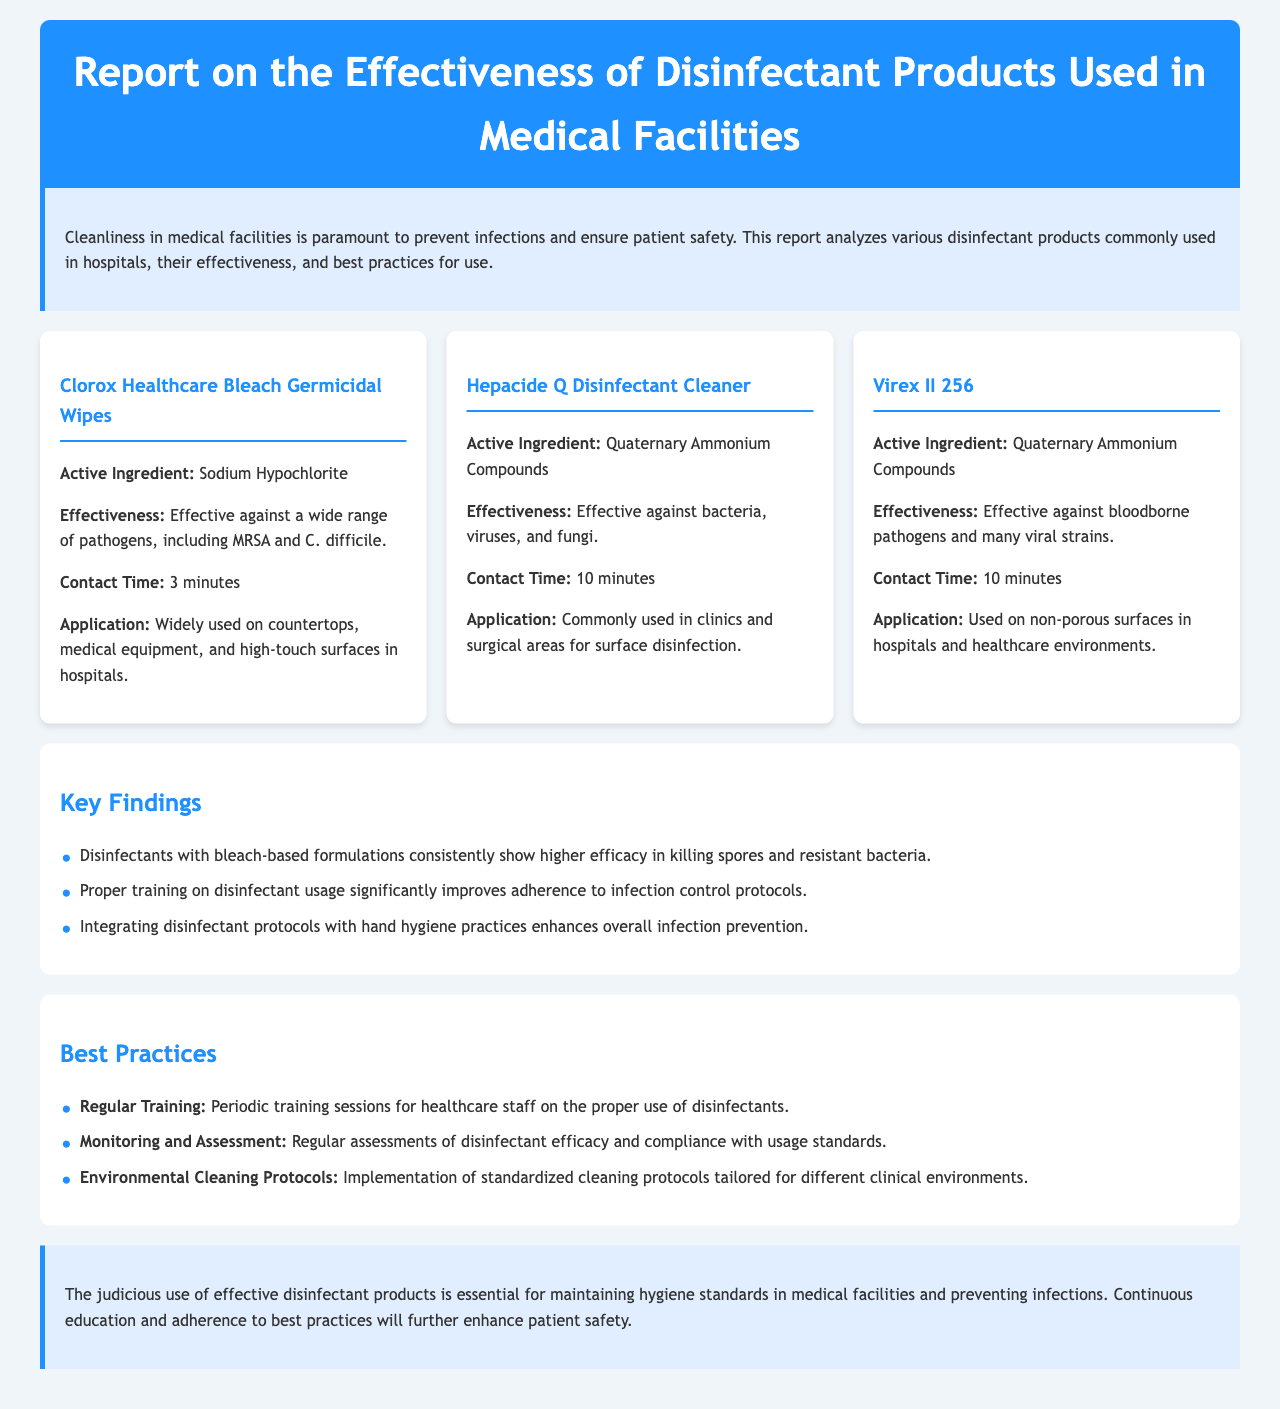What is the active ingredient in Clorox Healthcare Bleach Germicidal Wipes? The active ingredient mentioned in the document for Clorox Healthcare Bleach Germicidal Wipes is Sodium Hypochlorite.
Answer: Sodium Hypochlorite What environments is Hepacide Q Disinfectant Cleaner commonly used in? The document states that Hepacide Q Disinfectant Cleaner is commonly used in clinics and surgical areas for surface disinfection.
Answer: Clinics and surgical areas What is the contact time for Virex II 256? The document specifies that the contact time for Virex II 256 is 10 minutes.
Answer: 10 minutes Which disinfectant product is effective against a wide range of pathogens, including MRSA? Clorox Healthcare Bleach Germicidal Wipes is noted to be effective against a wide range of pathogens, including MRSA.
Answer: Clorox Healthcare Bleach Germicidal Wipes According to the findings, what enhances overall infection prevention? The findings suggest that integrating disinfectant protocols with hand hygiene practices enhances overall infection prevention.
Answer: Integrating disinfectant protocols with hand hygiene practices What is a best practice for healthcare staff regarding disinfectant usage? The report recommends regular training for healthcare staff on the proper use of disinfectants as a best practice.
Answer: Regular training What is the primary focus of the report? The primary focus of the report is to analyze the effectiveness of disinfectant products used in medical facilities and their role in preventing infections.
Answer: Effectiveness of disinfectant products How is the document structured? The document is structured into sections including an introduction, product information, key findings, best practices, and a conclusion.
Answer: Sections including introduction, product information, key findings, best practices, conclusion What was the conclusion of the report about disinfectant products? The conclusion emphasizes that the judicious use of effective disinfectant products is essential for maintaining hygiene standards and preventing infections.
Answer: Essential for maintaining hygiene standards and preventing infections 